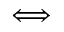<formula> <loc_0><loc_0><loc_500><loc_500>\Longleftrightarrow</formula> 